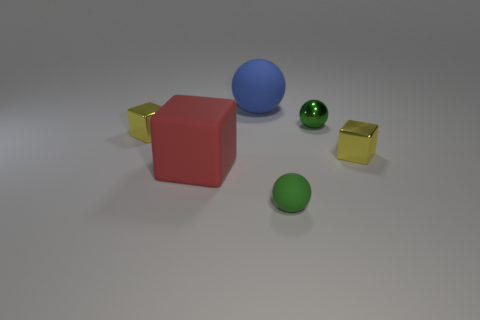Are there any other things that are the same material as the large red cube?
Your response must be concise. Yes. There is a sphere that is the same color as the small rubber object; what is its material?
Provide a succinct answer. Metal. Is there a small matte object that has the same color as the metallic ball?
Provide a short and direct response. Yes. There is a small rubber ball; is it the same color as the small sphere behind the large red cube?
Your answer should be very brief. Yes. There is a matte thing that is to the right of the blue sphere; are there any shiny cubes on the left side of it?
Make the answer very short. Yes. There is a tiny green thing that is made of the same material as the large cube; what is its shape?
Provide a succinct answer. Sphere. Is there anything else that has the same color as the big matte ball?
Your answer should be very brief. No. What is the tiny yellow object to the right of the rubber sphere that is in front of the big blue thing made of?
Your response must be concise. Metal. Is there a tiny green matte object of the same shape as the blue object?
Provide a succinct answer. Yes. How many other objects are the same shape as the blue rubber object?
Provide a short and direct response. 2. 